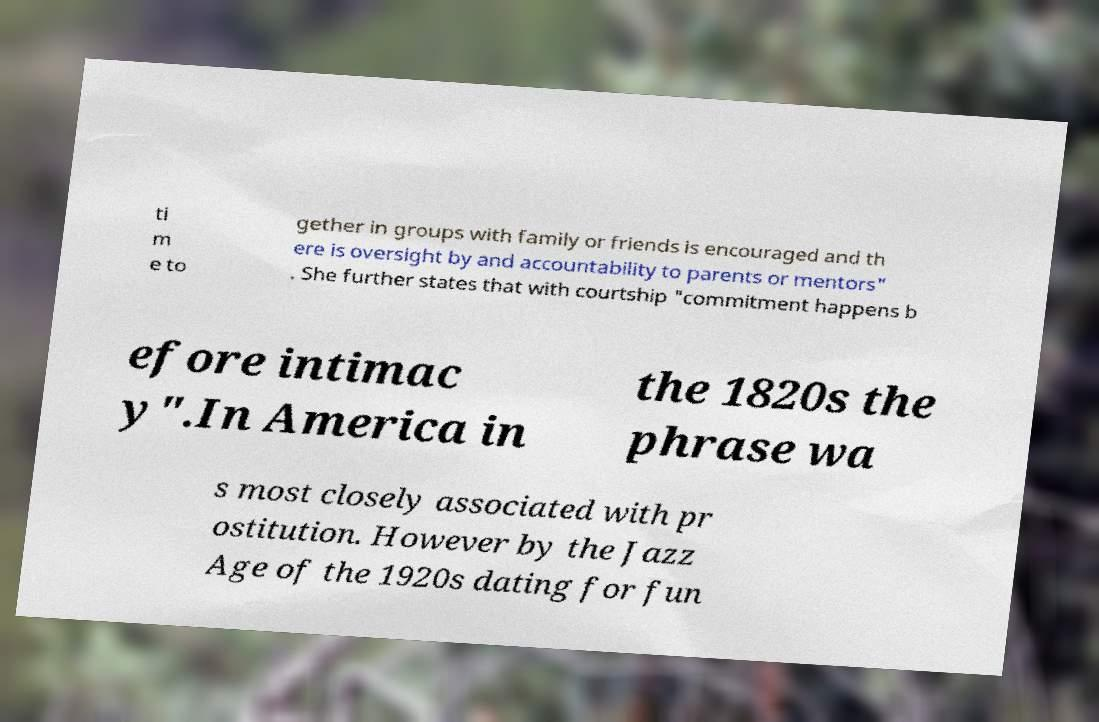Could you assist in decoding the text presented in this image and type it out clearly? ti m e to gether in groups with family or friends is encouraged and th ere is oversight by and accountability to parents or mentors" . She further states that with courtship "commitment happens b efore intimac y".In America in the 1820s the phrase wa s most closely associated with pr ostitution. However by the Jazz Age of the 1920s dating for fun 